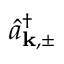Convert formula to latex. <formula><loc_0><loc_0><loc_500><loc_500>\hat { a } _ { k , \pm } ^ { \dagger }</formula> 